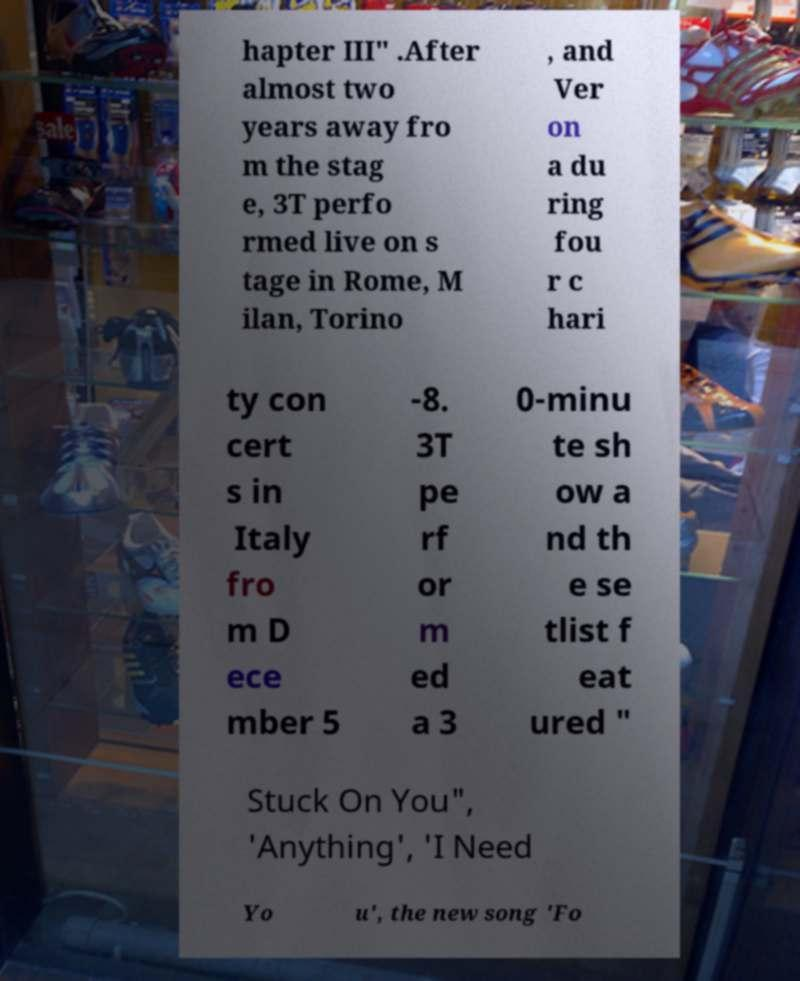There's text embedded in this image that I need extracted. Can you transcribe it verbatim? hapter III" .After almost two years away fro m the stag e, 3T perfo rmed live on s tage in Rome, M ilan, Torino , and Ver on a du ring fou r c hari ty con cert s in Italy fro m D ece mber 5 -8. 3T pe rf or m ed a 3 0-minu te sh ow a nd th e se tlist f eat ured " Stuck On You", 'Anything', 'I Need Yo u', the new song 'Fo 